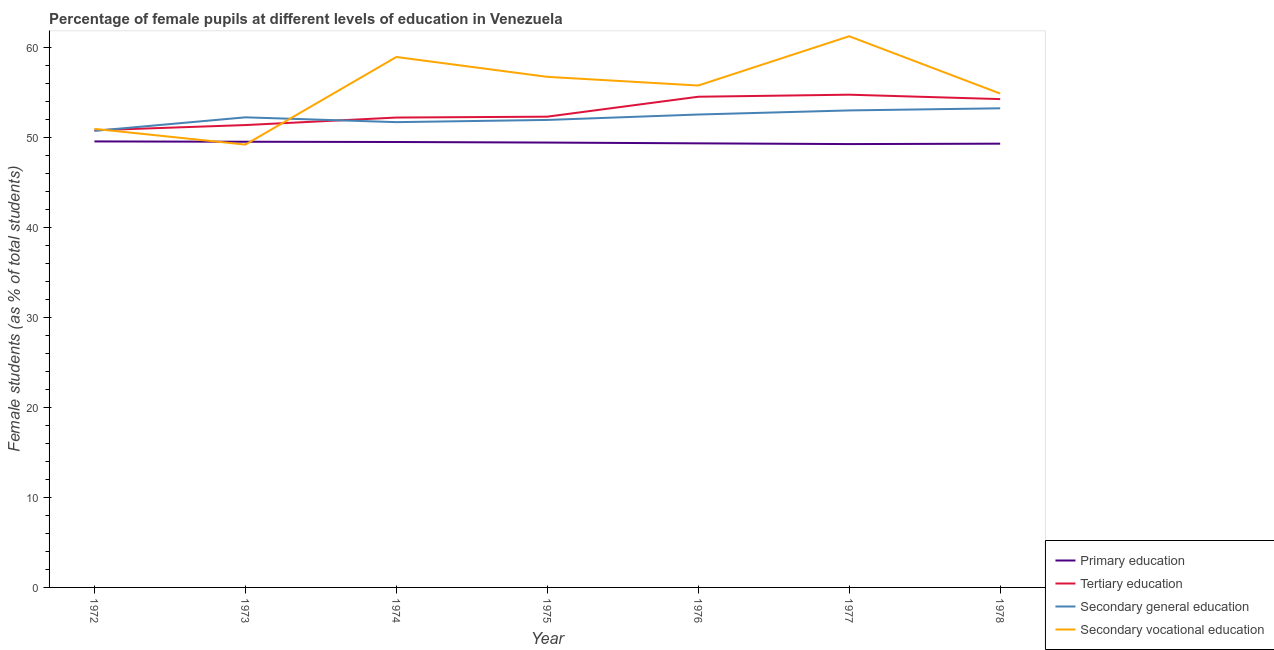Does the line corresponding to percentage of female students in tertiary education intersect with the line corresponding to percentage of female students in secondary vocational education?
Make the answer very short. Yes. Is the number of lines equal to the number of legend labels?
Provide a succinct answer. Yes. What is the percentage of female students in tertiary education in 1974?
Your answer should be compact. 52.25. Across all years, what is the maximum percentage of female students in secondary vocational education?
Provide a short and direct response. 61.29. Across all years, what is the minimum percentage of female students in secondary education?
Make the answer very short. 50.77. What is the total percentage of female students in secondary education in the graph?
Offer a terse response. 365.69. What is the difference between the percentage of female students in primary education in 1976 and that in 1977?
Offer a very short reply. 0.08. What is the difference between the percentage of female students in primary education in 1978 and the percentage of female students in secondary vocational education in 1977?
Offer a very short reply. -11.95. What is the average percentage of female students in primary education per year?
Your response must be concise. 49.46. In the year 1977, what is the difference between the percentage of female students in primary education and percentage of female students in tertiary education?
Make the answer very short. -5.49. In how many years, is the percentage of female students in primary education greater than 46 %?
Offer a very short reply. 7. What is the ratio of the percentage of female students in secondary education in 1972 to that in 1975?
Provide a short and direct response. 0.98. What is the difference between the highest and the second highest percentage of female students in tertiary education?
Your answer should be compact. 0.23. What is the difference between the highest and the lowest percentage of female students in secondary education?
Ensure brevity in your answer.  2.51. In how many years, is the percentage of female students in secondary vocational education greater than the average percentage of female students in secondary vocational education taken over all years?
Provide a succinct answer. 4. Is the sum of the percentage of female students in tertiary education in 1974 and 1977 greater than the maximum percentage of female students in secondary education across all years?
Make the answer very short. Yes. Is it the case that in every year, the sum of the percentage of female students in tertiary education and percentage of female students in primary education is greater than the sum of percentage of female students in secondary education and percentage of female students in secondary vocational education?
Your response must be concise. No. Is it the case that in every year, the sum of the percentage of female students in primary education and percentage of female students in tertiary education is greater than the percentage of female students in secondary education?
Your answer should be compact. Yes. Is the percentage of female students in secondary vocational education strictly less than the percentage of female students in primary education over the years?
Your answer should be compact. No. What is the difference between two consecutive major ticks on the Y-axis?
Give a very brief answer. 10. Are the values on the major ticks of Y-axis written in scientific E-notation?
Give a very brief answer. No. Where does the legend appear in the graph?
Provide a short and direct response. Bottom right. What is the title of the graph?
Provide a succinct answer. Percentage of female pupils at different levels of education in Venezuela. Does "Argument" appear as one of the legend labels in the graph?
Your answer should be very brief. No. What is the label or title of the X-axis?
Give a very brief answer. Year. What is the label or title of the Y-axis?
Give a very brief answer. Female students (as % of total students). What is the Female students (as % of total students) of Primary education in 1972?
Your answer should be compact. 49.6. What is the Female students (as % of total students) in Tertiary education in 1972?
Your answer should be very brief. 50.84. What is the Female students (as % of total students) of Secondary general education in 1972?
Provide a succinct answer. 50.77. What is the Female students (as % of total students) of Secondary vocational education in 1972?
Offer a terse response. 50.99. What is the Female students (as % of total students) in Primary education in 1973?
Your answer should be compact. 49.56. What is the Female students (as % of total students) of Tertiary education in 1973?
Your answer should be very brief. 51.42. What is the Female students (as % of total students) of Secondary general education in 1973?
Provide a short and direct response. 52.28. What is the Female students (as % of total students) in Secondary vocational education in 1973?
Your response must be concise. 49.24. What is the Female students (as % of total students) of Primary education in 1974?
Provide a succinct answer. 49.53. What is the Female students (as % of total students) of Tertiary education in 1974?
Your answer should be compact. 52.25. What is the Female students (as % of total students) of Secondary general education in 1974?
Ensure brevity in your answer.  51.74. What is the Female students (as % of total students) of Secondary vocational education in 1974?
Make the answer very short. 58.99. What is the Female students (as % of total students) in Primary education in 1975?
Offer a terse response. 49.47. What is the Female students (as % of total students) of Tertiary education in 1975?
Your answer should be very brief. 52.35. What is the Female students (as % of total students) in Secondary general education in 1975?
Offer a terse response. 51.99. What is the Female students (as % of total students) of Secondary vocational education in 1975?
Your answer should be very brief. 56.78. What is the Female students (as % of total students) in Primary education in 1976?
Your response must be concise. 49.38. What is the Female students (as % of total students) in Tertiary education in 1976?
Your response must be concise. 54.57. What is the Female students (as % of total students) of Secondary general education in 1976?
Give a very brief answer. 52.59. What is the Female students (as % of total students) of Secondary vocational education in 1976?
Offer a very short reply. 55.81. What is the Female students (as % of total students) in Primary education in 1977?
Make the answer very short. 49.3. What is the Female students (as % of total students) of Tertiary education in 1977?
Offer a very short reply. 54.79. What is the Female students (as % of total students) of Secondary general education in 1977?
Provide a succinct answer. 53.04. What is the Female students (as % of total students) of Secondary vocational education in 1977?
Your answer should be very brief. 61.29. What is the Female students (as % of total students) of Primary education in 1978?
Your answer should be compact. 49.35. What is the Female students (as % of total students) in Tertiary education in 1978?
Make the answer very short. 54.3. What is the Female students (as % of total students) of Secondary general education in 1978?
Give a very brief answer. 53.28. What is the Female students (as % of total students) of Secondary vocational education in 1978?
Offer a terse response. 54.92. Across all years, what is the maximum Female students (as % of total students) in Primary education?
Make the answer very short. 49.6. Across all years, what is the maximum Female students (as % of total students) in Tertiary education?
Your answer should be very brief. 54.79. Across all years, what is the maximum Female students (as % of total students) in Secondary general education?
Provide a short and direct response. 53.28. Across all years, what is the maximum Female students (as % of total students) of Secondary vocational education?
Ensure brevity in your answer.  61.29. Across all years, what is the minimum Female students (as % of total students) of Primary education?
Ensure brevity in your answer.  49.3. Across all years, what is the minimum Female students (as % of total students) in Tertiary education?
Give a very brief answer. 50.84. Across all years, what is the minimum Female students (as % of total students) of Secondary general education?
Your response must be concise. 50.77. Across all years, what is the minimum Female students (as % of total students) of Secondary vocational education?
Offer a terse response. 49.24. What is the total Female students (as % of total students) of Primary education in the graph?
Offer a terse response. 346.19. What is the total Female students (as % of total students) of Tertiary education in the graph?
Your answer should be very brief. 370.52. What is the total Female students (as % of total students) in Secondary general education in the graph?
Provide a short and direct response. 365.69. What is the total Female students (as % of total students) in Secondary vocational education in the graph?
Provide a short and direct response. 388.03. What is the difference between the Female students (as % of total students) in Primary education in 1972 and that in 1973?
Make the answer very short. 0.03. What is the difference between the Female students (as % of total students) in Tertiary education in 1972 and that in 1973?
Give a very brief answer. -0.58. What is the difference between the Female students (as % of total students) of Secondary general education in 1972 and that in 1973?
Offer a very short reply. -1.5. What is the difference between the Female students (as % of total students) of Secondary vocational education in 1972 and that in 1973?
Keep it short and to the point. 1.75. What is the difference between the Female students (as % of total students) in Primary education in 1972 and that in 1974?
Offer a very short reply. 0.06. What is the difference between the Female students (as % of total students) of Tertiary education in 1972 and that in 1974?
Offer a very short reply. -1.42. What is the difference between the Female students (as % of total students) in Secondary general education in 1972 and that in 1974?
Give a very brief answer. -0.97. What is the difference between the Female students (as % of total students) in Secondary vocational education in 1972 and that in 1974?
Provide a succinct answer. -7.99. What is the difference between the Female students (as % of total students) of Primary education in 1972 and that in 1975?
Ensure brevity in your answer.  0.13. What is the difference between the Female students (as % of total students) in Tertiary education in 1972 and that in 1975?
Keep it short and to the point. -1.51. What is the difference between the Female students (as % of total students) in Secondary general education in 1972 and that in 1975?
Provide a short and direct response. -1.21. What is the difference between the Female students (as % of total students) of Secondary vocational education in 1972 and that in 1975?
Your answer should be compact. -5.79. What is the difference between the Female students (as % of total students) in Primary education in 1972 and that in 1976?
Offer a very short reply. 0.21. What is the difference between the Female students (as % of total students) of Tertiary education in 1972 and that in 1976?
Offer a very short reply. -3.73. What is the difference between the Female students (as % of total students) of Secondary general education in 1972 and that in 1976?
Your answer should be very brief. -1.82. What is the difference between the Female students (as % of total students) in Secondary vocational education in 1972 and that in 1976?
Provide a succinct answer. -4.82. What is the difference between the Female students (as % of total students) in Primary education in 1972 and that in 1977?
Keep it short and to the point. 0.3. What is the difference between the Female students (as % of total students) in Tertiary education in 1972 and that in 1977?
Offer a terse response. -3.96. What is the difference between the Female students (as % of total students) in Secondary general education in 1972 and that in 1977?
Provide a succinct answer. -2.27. What is the difference between the Female students (as % of total students) in Secondary vocational education in 1972 and that in 1977?
Make the answer very short. -10.3. What is the difference between the Female students (as % of total students) in Primary education in 1972 and that in 1978?
Ensure brevity in your answer.  0.25. What is the difference between the Female students (as % of total students) in Tertiary education in 1972 and that in 1978?
Provide a short and direct response. -3.47. What is the difference between the Female students (as % of total students) of Secondary general education in 1972 and that in 1978?
Make the answer very short. -2.51. What is the difference between the Female students (as % of total students) in Secondary vocational education in 1972 and that in 1978?
Ensure brevity in your answer.  -3.93. What is the difference between the Female students (as % of total students) in Primary education in 1973 and that in 1974?
Provide a short and direct response. 0.03. What is the difference between the Female students (as % of total students) of Tertiary education in 1973 and that in 1974?
Offer a terse response. -0.83. What is the difference between the Female students (as % of total students) of Secondary general education in 1973 and that in 1974?
Provide a short and direct response. 0.53. What is the difference between the Female students (as % of total students) of Secondary vocational education in 1973 and that in 1974?
Your answer should be very brief. -9.74. What is the difference between the Female students (as % of total students) of Primary education in 1973 and that in 1975?
Provide a succinct answer. 0.09. What is the difference between the Female students (as % of total students) in Tertiary education in 1973 and that in 1975?
Your response must be concise. -0.93. What is the difference between the Female students (as % of total students) in Secondary general education in 1973 and that in 1975?
Provide a succinct answer. 0.29. What is the difference between the Female students (as % of total students) in Secondary vocational education in 1973 and that in 1975?
Your response must be concise. -7.53. What is the difference between the Female students (as % of total students) of Primary education in 1973 and that in 1976?
Make the answer very short. 0.18. What is the difference between the Female students (as % of total students) of Tertiary education in 1973 and that in 1976?
Give a very brief answer. -3.15. What is the difference between the Female students (as % of total students) of Secondary general education in 1973 and that in 1976?
Your response must be concise. -0.31. What is the difference between the Female students (as % of total students) in Secondary vocational education in 1973 and that in 1976?
Make the answer very short. -6.57. What is the difference between the Female students (as % of total students) of Primary education in 1973 and that in 1977?
Offer a very short reply. 0.26. What is the difference between the Female students (as % of total students) of Tertiary education in 1973 and that in 1977?
Provide a short and direct response. -3.38. What is the difference between the Female students (as % of total students) in Secondary general education in 1973 and that in 1977?
Your answer should be compact. -0.77. What is the difference between the Female students (as % of total students) in Secondary vocational education in 1973 and that in 1977?
Make the answer very short. -12.05. What is the difference between the Female students (as % of total students) of Primary education in 1973 and that in 1978?
Offer a terse response. 0.22. What is the difference between the Female students (as % of total students) in Tertiary education in 1973 and that in 1978?
Keep it short and to the point. -2.89. What is the difference between the Female students (as % of total students) of Secondary general education in 1973 and that in 1978?
Give a very brief answer. -1. What is the difference between the Female students (as % of total students) of Secondary vocational education in 1973 and that in 1978?
Ensure brevity in your answer.  -5.68. What is the difference between the Female students (as % of total students) of Primary education in 1974 and that in 1975?
Provide a succinct answer. 0.06. What is the difference between the Female students (as % of total students) of Tertiary education in 1974 and that in 1975?
Make the answer very short. -0.1. What is the difference between the Female students (as % of total students) in Secondary general education in 1974 and that in 1975?
Give a very brief answer. -0.24. What is the difference between the Female students (as % of total students) in Secondary vocational education in 1974 and that in 1975?
Offer a very short reply. 2.21. What is the difference between the Female students (as % of total students) in Primary education in 1974 and that in 1976?
Your response must be concise. 0.15. What is the difference between the Female students (as % of total students) in Tertiary education in 1974 and that in 1976?
Ensure brevity in your answer.  -2.31. What is the difference between the Female students (as % of total students) in Secondary general education in 1974 and that in 1976?
Provide a short and direct response. -0.85. What is the difference between the Female students (as % of total students) in Secondary vocational education in 1974 and that in 1976?
Make the answer very short. 3.17. What is the difference between the Female students (as % of total students) of Primary education in 1974 and that in 1977?
Give a very brief answer. 0.23. What is the difference between the Female students (as % of total students) of Tertiary education in 1974 and that in 1977?
Your answer should be compact. -2.54. What is the difference between the Female students (as % of total students) in Secondary general education in 1974 and that in 1977?
Provide a short and direct response. -1.3. What is the difference between the Female students (as % of total students) of Secondary vocational education in 1974 and that in 1977?
Your answer should be very brief. -2.31. What is the difference between the Female students (as % of total students) in Primary education in 1974 and that in 1978?
Provide a succinct answer. 0.19. What is the difference between the Female students (as % of total students) of Tertiary education in 1974 and that in 1978?
Provide a short and direct response. -2.05. What is the difference between the Female students (as % of total students) of Secondary general education in 1974 and that in 1978?
Make the answer very short. -1.54. What is the difference between the Female students (as % of total students) in Secondary vocational education in 1974 and that in 1978?
Make the answer very short. 4.06. What is the difference between the Female students (as % of total students) in Primary education in 1975 and that in 1976?
Your answer should be very brief. 0.09. What is the difference between the Female students (as % of total students) in Tertiary education in 1975 and that in 1976?
Offer a terse response. -2.22. What is the difference between the Female students (as % of total students) of Secondary general education in 1975 and that in 1976?
Ensure brevity in your answer.  -0.6. What is the difference between the Female students (as % of total students) in Secondary vocational education in 1975 and that in 1976?
Offer a terse response. 0.96. What is the difference between the Female students (as % of total students) of Primary education in 1975 and that in 1977?
Keep it short and to the point. 0.17. What is the difference between the Female students (as % of total students) in Tertiary education in 1975 and that in 1977?
Keep it short and to the point. -2.44. What is the difference between the Female students (as % of total students) in Secondary general education in 1975 and that in 1977?
Your answer should be compact. -1.06. What is the difference between the Female students (as % of total students) in Secondary vocational education in 1975 and that in 1977?
Give a very brief answer. -4.52. What is the difference between the Female students (as % of total students) in Primary education in 1975 and that in 1978?
Your response must be concise. 0.12. What is the difference between the Female students (as % of total students) of Tertiary education in 1975 and that in 1978?
Make the answer very short. -1.95. What is the difference between the Female students (as % of total students) of Secondary general education in 1975 and that in 1978?
Your response must be concise. -1.29. What is the difference between the Female students (as % of total students) of Secondary vocational education in 1975 and that in 1978?
Give a very brief answer. 1.86. What is the difference between the Female students (as % of total students) in Primary education in 1976 and that in 1977?
Give a very brief answer. 0.08. What is the difference between the Female students (as % of total students) in Tertiary education in 1976 and that in 1977?
Make the answer very short. -0.23. What is the difference between the Female students (as % of total students) of Secondary general education in 1976 and that in 1977?
Ensure brevity in your answer.  -0.46. What is the difference between the Female students (as % of total students) of Secondary vocational education in 1976 and that in 1977?
Provide a short and direct response. -5.48. What is the difference between the Female students (as % of total students) of Primary education in 1976 and that in 1978?
Make the answer very short. 0.04. What is the difference between the Female students (as % of total students) of Tertiary education in 1976 and that in 1978?
Provide a succinct answer. 0.26. What is the difference between the Female students (as % of total students) of Secondary general education in 1976 and that in 1978?
Your answer should be compact. -0.69. What is the difference between the Female students (as % of total students) of Secondary vocational education in 1976 and that in 1978?
Keep it short and to the point. 0.89. What is the difference between the Female students (as % of total students) of Primary education in 1977 and that in 1978?
Give a very brief answer. -0.05. What is the difference between the Female students (as % of total students) of Tertiary education in 1977 and that in 1978?
Provide a short and direct response. 0.49. What is the difference between the Female students (as % of total students) in Secondary general education in 1977 and that in 1978?
Keep it short and to the point. -0.24. What is the difference between the Female students (as % of total students) of Secondary vocational education in 1977 and that in 1978?
Offer a terse response. 6.37. What is the difference between the Female students (as % of total students) in Primary education in 1972 and the Female students (as % of total students) in Tertiary education in 1973?
Your response must be concise. -1.82. What is the difference between the Female students (as % of total students) of Primary education in 1972 and the Female students (as % of total students) of Secondary general education in 1973?
Keep it short and to the point. -2.68. What is the difference between the Female students (as % of total students) of Primary education in 1972 and the Female students (as % of total students) of Secondary vocational education in 1973?
Offer a terse response. 0.35. What is the difference between the Female students (as % of total students) of Tertiary education in 1972 and the Female students (as % of total students) of Secondary general education in 1973?
Provide a short and direct response. -1.44. What is the difference between the Female students (as % of total students) in Tertiary education in 1972 and the Female students (as % of total students) in Secondary vocational education in 1973?
Provide a succinct answer. 1.59. What is the difference between the Female students (as % of total students) of Secondary general education in 1972 and the Female students (as % of total students) of Secondary vocational education in 1973?
Your answer should be very brief. 1.53. What is the difference between the Female students (as % of total students) of Primary education in 1972 and the Female students (as % of total students) of Tertiary education in 1974?
Your response must be concise. -2.65. What is the difference between the Female students (as % of total students) of Primary education in 1972 and the Female students (as % of total students) of Secondary general education in 1974?
Your answer should be very brief. -2.14. What is the difference between the Female students (as % of total students) of Primary education in 1972 and the Female students (as % of total students) of Secondary vocational education in 1974?
Your response must be concise. -9.39. What is the difference between the Female students (as % of total students) in Tertiary education in 1972 and the Female students (as % of total students) in Secondary general education in 1974?
Your response must be concise. -0.91. What is the difference between the Female students (as % of total students) of Tertiary education in 1972 and the Female students (as % of total students) of Secondary vocational education in 1974?
Provide a succinct answer. -8.15. What is the difference between the Female students (as % of total students) of Secondary general education in 1972 and the Female students (as % of total students) of Secondary vocational education in 1974?
Your response must be concise. -8.21. What is the difference between the Female students (as % of total students) of Primary education in 1972 and the Female students (as % of total students) of Tertiary education in 1975?
Your answer should be compact. -2.75. What is the difference between the Female students (as % of total students) of Primary education in 1972 and the Female students (as % of total students) of Secondary general education in 1975?
Offer a very short reply. -2.39. What is the difference between the Female students (as % of total students) in Primary education in 1972 and the Female students (as % of total students) in Secondary vocational education in 1975?
Offer a very short reply. -7.18. What is the difference between the Female students (as % of total students) in Tertiary education in 1972 and the Female students (as % of total students) in Secondary general education in 1975?
Give a very brief answer. -1.15. What is the difference between the Female students (as % of total students) of Tertiary education in 1972 and the Female students (as % of total students) of Secondary vocational education in 1975?
Ensure brevity in your answer.  -5.94. What is the difference between the Female students (as % of total students) of Secondary general education in 1972 and the Female students (as % of total students) of Secondary vocational education in 1975?
Give a very brief answer. -6.01. What is the difference between the Female students (as % of total students) in Primary education in 1972 and the Female students (as % of total students) in Tertiary education in 1976?
Provide a succinct answer. -4.97. What is the difference between the Female students (as % of total students) of Primary education in 1972 and the Female students (as % of total students) of Secondary general education in 1976?
Offer a very short reply. -2.99. What is the difference between the Female students (as % of total students) in Primary education in 1972 and the Female students (as % of total students) in Secondary vocational education in 1976?
Provide a succinct answer. -6.22. What is the difference between the Female students (as % of total students) of Tertiary education in 1972 and the Female students (as % of total students) of Secondary general education in 1976?
Offer a very short reply. -1.75. What is the difference between the Female students (as % of total students) in Tertiary education in 1972 and the Female students (as % of total students) in Secondary vocational education in 1976?
Ensure brevity in your answer.  -4.98. What is the difference between the Female students (as % of total students) in Secondary general education in 1972 and the Female students (as % of total students) in Secondary vocational education in 1976?
Make the answer very short. -5.04. What is the difference between the Female students (as % of total students) of Primary education in 1972 and the Female students (as % of total students) of Tertiary education in 1977?
Provide a succinct answer. -5.2. What is the difference between the Female students (as % of total students) of Primary education in 1972 and the Female students (as % of total students) of Secondary general education in 1977?
Offer a terse response. -3.45. What is the difference between the Female students (as % of total students) of Primary education in 1972 and the Female students (as % of total students) of Secondary vocational education in 1977?
Ensure brevity in your answer.  -11.7. What is the difference between the Female students (as % of total students) of Tertiary education in 1972 and the Female students (as % of total students) of Secondary general education in 1977?
Your answer should be very brief. -2.21. What is the difference between the Female students (as % of total students) of Tertiary education in 1972 and the Female students (as % of total students) of Secondary vocational education in 1977?
Give a very brief answer. -10.46. What is the difference between the Female students (as % of total students) in Secondary general education in 1972 and the Female students (as % of total students) in Secondary vocational education in 1977?
Your response must be concise. -10.52. What is the difference between the Female students (as % of total students) of Primary education in 1972 and the Female students (as % of total students) of Tertiary education in 1978?
Your answer should be very brief. -4.71. What is the difference between the Female students (as % of total students) of Primary education in 1972 and the Female students (as % of total students) of Secondary general education in 1978?
Keep it short and to the point. -3.68. What is the difference between the Female students (as % of total students) in Primary education in 1972 and the Female students (as % of total students) in Secondary vocational education in 1978?
Ensure brevity in your answer.  -5.32. What is the difference between the Female students (as % of total students) of Tertiary education in 1972 and the Female students (as % of total students) of Secondary general education in 1978?
Ensure brevity in your answer.  -2.44. What is the difference between the Female students (as % of total students) in Tertiary education in 1972 and the Female students (as % of total students) in Secondary vocational education in 1978?
Your answer should be very brief. -4.08. What is the difference between the Female students (as % of total students) of Secondary general education in 1972 and the Female students (as % of total students) of Secondary vocational education in 1978?
Provide a short and direct response. -4.15. What is the difference between the Female students (as % of total students) of Primary education in 1973 and the Female students (as % of total students) of Tertiary education in 1974?
Give a very brief answer. -2.69. What is the difference between the Female students (as % of total students) of Primary education in 1973 and the Female students (as % of total students) of Secondary general education in 1974?
Ensure brevity in your answer.  -2.18. What is the difference between the Female students (as % of total students) in Primary education in 1973 and the Female students (as % of total students) in Secondary vocational education in 1974?
Make the answer very short. -9.42. What is the difference between the Female students (as % of total students) of Tertiary education in 1973 and the Female students (as % of total students) of Secondary general education in 1974?
Provide a short and direct response. -0.33. What is the difference between the Female students (as % of total students) of Tertiary education in 1973 and the Female students (as % of total students) of Secondary vocational education in 1974?
Your answer should be very brief. -7.57. What is the difference between the Female students (as % of total students) of Secondary general education in 1973 and the Female students (as % of total students) of Secondary vocational education in 1974?
Provide a short and direct response. -6.71. What is the difference between the Female students (as % of total students) of Primary education in 1973 and the Female students (as % of total students) of Tertiary education in 1975?
Provide a succinct answer. -2.79. What is the difference between the Female students (as % of total students) of Primary education in 1973 and the Female students (as % of total students) of Secondary general education in 1975?
Your response must be concise. -2.42. What is the difference between the Female students (as % of total students) in Primary education in 1973 and the Female students (as % of total students) in Secondary vocational education in 1975?
Your answer should be very brief. -7.22. What is the difference between the Female students (as % of total students) of Tertiary education in 1973 and the Female students (as % of total students) of Secondary general education in 1975?
Provide a succinct answer. -0.57. What is the difference between the Female students (as % of total students) of Tertiary education in 1973 and the Female students (as % of total students) of Secondary vocational education in 1975?
Your answer should be very brief. -5.36. What is the difference between the Female students (as % of total students) in Secondary general education in 1973 and the Female students (as % of total students) in Secondary vocational education in 1975?
Ensure brevity in your answer.  -4.5. What is the difference between the Female students (as % of total students) in Primary education in 1973 and the Female students (as % of total students) in Tertiary education in 1976?
Make the answer very short. -5. What is the difference between the Female students (as % of total students) in Primary education in 1973 and the Female students (as % of total students) in Secondary general education in 1976?
Your answer should be compact. -3.03. What is the difference between the Female students (as % of total students) in Primary education in 1973 and the Female students (as % of total students) in Secondary vocational education in 1976?
Provide a short and direct response. -6.25. What is the difference between the Female students (as % of total students) of Tertiary education in 1973 and the Female students (as % of total students) of Secondary general education in 1976?
Your response must be concise. -1.17. What is the difference between the Female students (as % of total students) in Tertiary education in 1973 and the Female students (as % of total students) in Secondary vocational education in 1976?
Provide a succinct answer. -4.4. What is the difference between the Female students (as % of total students) of Secondary general education in 1973 and the Female students (as % of total students) of Secondary vocational education in 1976?
Make the answer very short. -3.54. What is the difference between the Female students (as % of total students) in Primary education in 1973 and the Female students (as % of total students) in Tertiary education in 1977?
Your response must be concise. -5.23. What is the difference between the Female students (as % of total students) of Primary education in 1973 and the Female students (as % of total students) of Secondary general education in 1977?
Offer a terse response. -3.48. What is the difference between the Female students (as % of total students) of Primary education in 1973 and the Female students (as % of total students) of Secondary vocational education in 1977?
Offer a very short reply. -11.73. What is the difference between the Female students (as % of total students) of Tertiary education in 1973 and the Female students (as % of total students) of Secondary general education in 1977?
Your response must be concise. -1.63. What is the difference between the Female students (as % of total students) of Tertiary education in 1973 and the Female students (as % of total students) of Secondary vocational education in 1977?
Your answer should be compact. -9.88. What is the difference between the Female students (as % of total students) of Secondary general education in 1973 and the Female students (as % of total students) of Secondary vocational education in 1977?
Your answer should be very brief. -9.02. What is the difference between the Female students (as % of total students) in Primary education in 1973 and the Female students (as % of total students) in Tertiary education in 1978?
Your response must be concise. -4.74. What is the difference between the Female students (as % of total students) in Primary education in 1973 and the Female students (as % of total students) in Secondary general education in 1978?
Give a very brief answer. -3.72. What is the difference between the Female students (as % of total students) of Primary education in 1973 and the Female students (as % of total students) of Secondary vocational education in 1978?
Your answer should be very brief. -5.36. What is the difference between the Female students (as % of total students) of Tertiary education in 1973 and the Female students (as % of total students) of Secondary general education in 1978?
Give a very brief answer. -1.86. What is the difference between the Female students (as % of total students) of Tertiary education in 1973 and the Female students (as % of total students) of Secondary vocational education in 1978?
Provide a short and direct response. -3.5. What is the difference between the Female students (as % of total students) in Secondary general education in 1973 and the Female students (as % of total students) in Secondary vocational education in 1978?
Ensure brevity in your answer.  -2.64. What is the difference between the Female students (as % of total students) in Primary education in 1974 and the Female students (as % of total students) in Tertiary education in 1975?
Provide a succinct answer. -2.82. What is the difference between the Female students (as % of total students) in Primary education in 1974 and the Female students (as % of total students) in Secondary general education in 1975?
Make the answer very short. -2.45. What is the difference between the Female students (as % of total students) in Primary education in 1974 and the Female students (as % of total students) in Secondary vocational education in 1975?
Provide a succinct answer. -7.25. What is the difference between the Female students (as % of total students) of Tertiary education in 1974 and the Female students (as % of total students) of Secondary general education in 1975?
Offer a very short reply. 0.27. What is the difference between the Female students (as % of total students) in Tertiary education in 1974 and the Female students (as % of total students) in Secondary vocational education in 1975?
Your answer should be very brief. -4.53. What is the difference between the Female students (as % of total students) of Secondary general education in 1974 and the Female students (as % of total students) of Secondary vocational education in 1975?
Your response must be concise. -5.04. What is the difference between the Female students (as % of total students) of Primary education in 1974 and the Female students (as % of total students) of Tertiary education in 1976?
Make the answer very short. -5.03. What is the difference between the Female students (as % of total students) in Primary education in 1974 and the Female students (as % of total students) in Secondary general education in 1976?
Offer a very short reply. -3.06. What is the difference between the Female students (as % of total students) of Primary education in 1974 and the Female students (as % of total students) of Secondary vocational education in 1976?
Your answer should be very brief. -6.28. What is the difference between the Female students (as % of total students) in Tertiary education in 1974 and the Female students (as % of total students) in Secondary general education in 1976?
Offer a terse response. -0.34. What is the difference between the Female students (as % of total students) of Tertiary education in 1974 and the Female students (as % of total students) of Secondary vocational education in 1976?
Provide a short and direct response. -3.56. What is the difference between the Female students (as % of total students) in Secondary general education in 1974 and the Female students (as % of total students) in Secondary vocational education in 1976?
Provide a short and direct response. -4.07. What is the difference between the Female students (as % of total students) in Primary education in 1974 and the Female students (as % of total students) in Tertiary education in 1977?
Provide a short and direct response. -5.26. What is the difference between the Female students (as % of total students) in Primary education in 1974 and the Female students (as % of total students) in Secondary general education in 1977?
Ensure brevity in your answer.  -3.51. What is the difference between the Female students (as % of total students) of Primary education in 1974 and the Female students (as % of total students) of Secondary vocational education in 1977?
Offer a terse response. -11.76. What is the difference between the Female students (as % of total students) of Tertiary education in 1974 and the Female students (as % of total students) of Secondary general education in 1977?
Keep it short and to the point. -0.79. What is the difference between the Female students (as % of total students) in Tertiary education in 1974 and the Female students (as % of total students) in Secondary vocational education in 1977?
Offer a terse response. -9.04. What is the difference between the Female students (as % of total students) of Secondary general education in 1974 and the Female students (as % of total students) of Secondary vocational education in 1977?
Ensure brevity in your answer.  -9.55. What is the difference between the Female students (as % of total students) in Primary education in 1974 and the Female students (as % of total students) in Tertiary education in 1978?
Make the answer very short. -4.77. What is the difference between the Female students (as % of total students) in Primary education in 1974 and the Female students (as % of total students) in Secondary general education in 1978?
Give a very brief answer. -3.75. What is the difference between the Female students (as % of total students) of Primary education in 1974 and the Female students (as % of total students) of Secondary vocational education in 1978?
Keep it short and to the point. -5.39. What is the difference between the Female students (as % of total students) of Tertiary education in 1974 and the Female students (as % of total students) of Secondary general education in 1978?
Offer a terse response. -1.03. What is the difference between the Female students (as % of total students) of Tertiary education in 1974 and the Female students (as % of total students) of Secondary vocational education in 1978?
Your response must be concise. -2.67. What is the difference between the Female students (as % of total students) of Secondary general education in 1974 and the Female students (as % of total students) of Secondary vocational education in 1978?
Your answer should be compact. -3.18. What is the difference between the Female students (as % of total students) of Primary education in 1975 and the Female students (as % of total students) of Tertiary education in 1976?
Offer a terse response. -5.09. What is the difference between the Female students (as % of total students) of Primary education in 1975 and the Female students (as % of total students) of Secondary general education in 1976?
Ensure brevity in your answer.  -3.12. What is the difference between the Female students (as % of total students) in Primary education in 1975 and the Female students (as % of total students) in Secondary vocational education in 1976?
Offer a very short reply. -6.34. What is the difference between the Female students (as % of total students) in Tertiary education in 1975 and the Female students (as % of total students) in Secondary general education in 1976?
Keep it short and to the point. -0.24. What is the difference between the Female students (as % of total students) of Tertiary education in 1975 and the Female students (as % of total students) of Secondary vocational education in 1976?
Provide a succinct answer. -3.46. What is the difference between the Female students (as % of total students) of Secondary general education in 1975 and the Female students (as % of total students) of Secondary vocational education in 1976?
Provide a succinct answer. -3.83. What is the difference between the Female students (as % of total students) of Primary education in 1975 and the Female students (as % of total students) of Tertiary education in 1977?
Keep it short and to the point. -5.32. What is the difference between the Female students (as % of total students) of Primary education in 1975 and the Female students (as % of total students) of Secondary general education in 1977?
Your response must be concise. -3.57. What is the difference between the Female students (as % of total students) of Primary education in 1975 and the Female students (as % of total students) of Secondary vocational education in 1977?
Provide a short and direct response. -11.82. What is the difference between the Female students (as % of total students) in Tertiary education in 1975 and the Female students (as % of total students) in Secondary general education in 1977?
Keep it short and to the point. -0.69. What is the difference between the Female students (as % of total students) in Tertiary education in 1975 and the Female students (as % of total students) in Secondary vocational education in 1977?
Offer a terse response. -8.94. What is the difference between the Female students (as % of total students) of Secondary general education in 1975 and the Female students (as % of total students) of Secondary vocational education in 1977?
Keep it short and to the point. -9.31. What is the difference between the Female students (as % of total students) in Primary education in 1975 and the Female students (as % of total students) in Tertiary education in 1978?
Offer a very short reply. -4.83. What is the difference between the Female students (as % of total students) in Primary education in 1975 and the Female students (as % of total students) in Secondary general education in 1978?
Your response must be concise. -3.81. What is the difference between the Female students (as % of total students) in Primary education in 1975 and the Female students (as % of total students) in Secondary vocational education in 1978?
Your response must be concise. -5.45. What is the difference between the Female students (as % of total students) of Tertiary education in 1975 and the Female students (as % of total students) of Secondary general education in 1978?
Keep it short and to the point. -0.93. What is the difference between the Female students (as % of total students) of Tertiary education in 1975 and the Female students (as % of total students) of Secondary vocational education in 1978?
Keep it short and to the point. -2.57. What is the difference between the Female students (as % of total students) of Secondary general education in 1975 and the Female students (as % of total students) of Secondary vocational education in 1978?
Provide a succinct answer. -2.94. What is the difference between the Female students (as % of total students) in Primary education in 1976 and the Female students (as % of total students) in Tertiary education in 1977?
Ensure brevity in your answer.  -5.41. What is the difference between the Female students (as % of total students) in Primary education in 1976 and the Female students (as % of total students) in Secondary general education in 1977?
Give a very brief answer. -3.66. What is the difference between the Female students (as % of total students) of Primary education in 1976 and the Female students (as % of total students) of Secondary vocational education in 1977?
Your answer should be very brief. -11.91. What is the difference between the Female students (as % of total students) in Tertiary education in 1976 and the Female students (as % of total students) in Secondary general education in 1977?
Your answer should be compact. 1.52. What is the difference between the Female students (as % of total students) in Tertiary education in 1976 and the Female students (as % of total students) in Secondary vocational education in 1977?
Ensure brevity in your answer.  -6.73. What is the difference between the Female students (as % of total students) of Secondary general education in 1976 and the Female students (as % of total students) of Secondary vocational education in 1977?
Your response must be concise. -8.7. What is the difference between the Female students (as % of total students) in Primary education in 1976 and the Female students (as % of total students) in Tertiary education in 1978?
Ensure brevity in your answer.  -4.92. What is the difference between the Female students (as % of total students) in Primary education in 1976 and the Female students (as % of total students) in Secondary general education in 1978?
Offer a very short reply. -3.9. What is the difference between the Female students (as % of total students) of Primary education in 1976 and the Female students (as % of total students) of Secondary vocational education in 1978?
Your response must be concise. -5.54. What is the difference between the Female students (as % of total students) in Tertiary education in 1976 and the Female students (as % of total students) in Secondary general education in 1978?
Your answer should be very brief. 1.29. What is the difference between the Female students (as % of total students) in Tertiary education in 1976 and the Female students (as % of total students) in Secondary vocational education in 1978?
Your answer should be compact. -0.35. What is the difference between the Female students (as % of total students) in Secondary general education in 1976 and the Female students (as % of total students) in Secondary vocational education in 1978?
Offer a terse response. -2.33. What is the difference between the Female students (as % of total students) in Primary education in 1977 and the Female students (as % of total students) in Tertiary education in 1978?
Offer a terse response. -5. What is the difference between the Female students (as % of total students) in Primary education in 1977 and the Female students (as % of total students) in Secondary general education in 1978?
Provide a short and direct response. -3.98. What is the difference between the Female students (as % of total students) of Primary education in 1977 and the Female students (as % of total students) of Secondary vocational education in 1978?
Your answer should be compact. -5.62. What is the difference between the Female students (as % of total students) in Tertiary education in 1977 and the Female students (as % of total students) in Secondary general education in 1978?
Offer a very short reply. 1.51. What is the difference between the Female students (as % of total students) in Tertiary education in 1977 and the Female students (as % of total students) in Secondary vocational education in 1978?
Make the answer very short. -0.13. What is the difference between the Female students (as % of total students) of Secondary general education in 1977 and the Female students (as % of total students) of Secondary vocational education in 1978?
Ensure brevity in your answer.  -1.88. What is the average Female students (as % of total students) of Primary education per year?
Your answer should be compact. 49.46. What is the average Female students (as % of total students) in Tertiary education per year?
Provide a succinct answer. 52.93. What is the average Female students (as % of total students) in Secondary general education per year?
Provide a short and direct response. 52.24. What is the average Female students (as % of total students) in Secondary vocational education per year?
Ensure brevity in your answer.  55.43. In the year 1972, what is the difference between the Female students (as % of total students) of Primary education and Female students (as % of total students) of Tertiary education?
Ensure brevity in your answer.  -1.24. In the year 1972, what is the difference between the Female students (as % of total students) in Primary education and Female students (as % of total students) in Secondary general education?
Ensure brevity in your answer.  -1.18. In the year 1972, what is the difference between the Female students (as % of total students) in Primary education and Female students (as % of total students) in Secondary vocational education?
Give a very brief answer. -1.4. In the year 1972, what is the difference between the Female students (as % of total students) of Tertiary education and Female students (as % of total students) of Secondary general education?
Provide a short and direct response. 0.06. In the year 1972, what is the difference between the Female students (as % of total students) of Tertiary education and Female students (as % of total students) of Secondary vocational education?
Ensure brevity in your answer.  -0.16. In the year 1972, what is the difference between the Female students (as % of total students) in Secondary general education and Female students (as % of total students) in Secondary vocational education?
Offer a very short reply. -0.22. In the year 1973, what is the difference between the Female students (as % of total students) of Primary education and Female students (as % of total students) of Tertiary education?
Provide a short and direct response. -1.85. In the year 1973, what is the difference between the Female students (as % of total students) in Primary education and Female students (as % of total students) in Secondary general education?
Give a very brief answer. -2.71. In the year 1973, what is the difference between the Female students (as % of total students) of Primary education and Female students (as % of total students) of Secondary vocational education?
Give a very brief answer. 0.32. In the year 1973, what is the difference between the Female students (as % of total students) in Tertiary education and Female students (as % of total students) in Secondary general education?
Give a very brief answer. -0.86. In the year 1973, what is the difference between the Female students (as % of total students) in Tertiary education and Female students (as % of total students) in Secondary vocational education?
Offer a very short reply. 2.17. In the year 1973, what is the difference between the Female students (as % of total students) of Secondary general education and Female students (as % of total students) of Secondary vocational education?
Your answer should be compact. 3.03. In the year 1974, what is the difference between the Female students (as % of total students) of Primary education and Female students (as % of total students) of Tertiary education?
Make the answer very short. -2.72. In the year 1974, what is the difference between the Female students (as % of total students) of Primary education and Female students (as % of total students) of Secondary general education?
Offer a very short reply. -2.21. In the year 1974, what is the difference between the Female students (as % of total students) of Primary education and Female students (as % of total students) of Secondary vocational education?
Provide a succinct answer. -9.45. In the year 1974, what is the difference between the Female students (as % of total students) in Tertiary education and Female students (as % of total students) in Secondary general education?
Offer a very short reply. 0.51. In the year 1974, what is the difference between the Female students (as % of total students) of Tertiary education and Female students (as % of total students) of Secondary vocational education?
Your answer should be compact. -6.73. In the year 1974, what is the difference between the Female students (as % of total students) of Secondary general education and Female students (as % of total students) of Secondary vocational education?
Your answer should be very brief. -7.24. In the year 1975, what is the difference between the Female students (as % of total students) of Primary education and Female students (as % of total students) of Tertiary education?
Keep it short and to the point. -2.88. In the year 1975, what is the difference between the Female students (as % of total students) in Primary education and Female students (as % of total students) in Secondary general education?
Provide a short and direct response. -2.51. In the year 1975, what is the difference between the Female students (as % of total students) of Primary education and Female students (as % of total students) of Secondary vocational education?
Ensure brevity in your answer.  -7.31. In the year 1975, what is the difference between the Female students (as % of total students) in Tertiary education and Female students (as % of total students) in Secondary general education?
Offer a very short reply. 0.36. In the year 1975, what is the difference between the Female students (as % of total students) of Tertiary education and Female students (as % of total students) of Secondary vocational education?
Keep it short and to the point. -4.43. In the year 1975, what is the difference between the Female students (as % of total students) of Secondary general education and Female students (as % of total students) of Secondary vocational education?
Your answer should be compact. -4.79. In the year 1976, what is the difference between the Female students (as % of total students) in Primary education and Female students (as % of total students) in Tertiary education?
Ensure brevity in your answer.  -5.18. In the year 1976, what is the difference between the Female students (as % of total students) in Primary education and Female students (as % of total students) in Secondary general education?
Your answer should be compact. -3.21. In the year 1976, what is the difference between the Female students (as % of total students) of Primary education and Female students (as % of total students) of Secondary vocational education?
Offer a terse response. -6.43. In the year 1976, what is the difference between the Female students (as % of total students) in Tertiary education and Female students (as % of total students) in Secondary general education?
Keep it short and to the point. 1.98. In the year 1976, what is the difference between the Female students (as % of total students) of Tertiary education and Female students (as % of total students) of Secondary vocational education?
Keep it short and to the point. -1.25. In the year 1976, what is the difference between the Female students (as % of total students) in Secondary general education and Female students (as % of total students) in Secondary vocational education?
Provide a short and direct response. -3.22. In the year 1977, what is the difference between the Female students (as % of total students) of Primary education and Female students (as % of total students) of Tertiary education?
Ensure brevity in your answer.  -5.49. In the year 1977, what is the difference between the Female students (as % of total students) in Primary education and Female students (as % of total students) in Secondary general education?
Keep it short and to the point. -3.74. In the year 1977, what is the difference between the Female students (as % of total students) in Primary education and Female students (as % of total students) in Secondary vocational education?
Ensure brevity in your answer.  -11.99. In the year 1977, what is the difference between the Female students (as % of total students) in Tertiary education and Female students (as % of total students) in Secondary general education?
Make the answer very short. 1.75. In the year 1977, what is the difference between the Female students (as % of total students) in Tertiary education and Female students (as % of total students) in Secondary vocational education?
Make the answer very short. -6.5. In the year 1977, what is the difference between the Female students (as % of total students) in Secondary general education and Female students (as % of total students) in Secondary vocational education?
Your answer should be very brief. -8.25. In the year 1978, what is the difference between the Female students (as % of total students) of Primary education and Female students (as % of total students) of Tertiary education?
Provide a succinct answer. -4.96. In the year 1978, what is the difference between the Female students (as % of total students) in Primary education and Female students (as % of total students) in Secondary general education?
Your answer should be compact. -3.93. In the year 1978, what is the difference between the Female students (as % of total students) in Primary education and Female students (as % of total students) in Secondary vocational education?
Your answer should be compact. -5.57. In the year 1978, what is the difference between the Female students (as % of total students) of Tertiary education and Female students (as % of total students) of Secondary general education?
Provide a succinct answer. 1.02. In the year 1978, what is the difference between the Female students (as % of total students) in Tertiary education and Female students (as % of total students) in Secondary vocational education?
Your answer should be very brief. -0.62. In the year 1978, what is the difference between the Female students (as % of total students) in Secondary general education and Female students (as % of total students) in Secondary vocational education?
Provide a succinct answer. -1.64. What is the ratio of the Female students (as % of total students) of Tertiary education in 1972 to that in 1973?
Provide a short and direct response. 0.99. What is the ratio of the Female students (as % of total students) of Secondary general education in 1972 to that in 1973?
Your response must be concise. 0.97. What is the ratio of the Female students (as % of total students) of Secondary vocational education in 1972 to that in 1973?
Provide a short and direct response. 1.04. What is the ratio of the Female students (as % of total students) in Primary education in 1972 to that in 1974?
Provide a short and direct response. 1. What is the ratio of the Female students (as % of total students) in Tertiary education in 1972 to that in 1974?
Keep it short and to the point. 0.97. What is the ratio of the Female students (as % of total students) of Secondary general education in 1972 to that in 1974?
Offer a terse response. 0.98. What is the ratio of the Female students (as % of total students) of Secondary vocational education in 1972 to that in 1974?
Keep it short and to the point. 0.86. What is the ratio of the Female students (as % of total students) in Tertiary education in 1972 to that in 1975?
Offer a very short reply. 0.97. What is the ratio of the Female students (as % of total students) in Secondary general education in 1972 to that in 1975?
Make the answer very short. 0.98. What is the ratio of the Female students (as % of total students) in Secondary vocational education in 1972 to that in 1975?
Your answer should be compact. 0.9. What is the ratio of the Female students (as % of total students) in Tertiary education in 1972 to that in 1976?
Offer a very short reply. 0.93. What is the ratio of the Female students (as % of total students) in Secondary general education in 1972 to that in 1976?
Offer a very short reply. 0.97. What is the ratio of the Female students (as % of total students) of Secondary vocational education in 1972 to that in 1976?
Your answer should be very brief. 0.91. What is the ratio of the Female students (as % of total students) of Primary education in 1972 to that in 1977?
Offer a terse response. 1.01. What is the ratio of the Female students (as % of total students) of Tertiary education in 1972 to that in 1977?
Make the answer very short. 0.93. What is the ratio of the Female students (as % of total students) of Secondary general education in 1972 to that in 1977?
Ensure brevity in your answer.  0.96. What is the ratio of the Female students (as % of total students) of Secondary vocational education in 1972 to that in 1977?
Offer a very short reply. 0.83. What is the ratio of the Female students (as % of total students) of Primary education in 1972 to that in 1978?
Keep it short and to the point. 1.01. What is the ratio of the Female students (as % of total students) of Tertiary education in 1972 to that in 1978?
Ensure brevity in your answer.  0.94. What is the ratio of the Female students (as % of total students) in Secondary general education in 1972 to that in 1978?
Provide a short and direct response. 0.95. What is the ratio of the Female students (as % of total students) in Secondary vocational education in 1972 to that in 1978?
Your answer should be very brief. 0.93. What is the ratio of the Female students (as % of total students) of Primary education in 1973 to that in 1974?
Your answer should be compact. 1. What is the ratio of the Female students (as % of total students) in Secondary general education in 1973 to that in 1974?
Your answer should be compact. 1.01. What is the ratio of the Female students (as % of total students) in Secondary vocational education in 1973 to that in 1974?
Provide a succinct answer. 0.83. What is the ratio of the Female students (as % of total students) of Primary education in 1973 to that in 1975?
Keep it short and to the point. 1. What is the ratio of the Female students (as % of total students) of Tertiary education in 1973 to that in 1975?
Your answer should be very brief. 0.98. What is the ratio of the Female students (as % of total students) in Secondary general education in 1973 to that in 1975?
Keep it short and to the point. 1.01. What is the ratio of the Female students (as % of total students) of Secondary vocational education in 1973 to that in 1975?
Provide a short and direct response. 0.87. What is the ratio of the Female students (as % of total students) of Primary education in 1973 to that in 1976?
Ensure brevity in your answer.  1. What is the ratio of the Female students (as % of total students) of Tertiary education in 1973 to that in 1976?
Provide a short and direct response. 0.94. What is the ratio of the Female students (as % of total students) of Secondary general education in 1973 to that in 1976?
Ensure brevity in your answer.  0.99. What is the ratio of the Female students (as % of total students) of Secondary vocational education in 1973 to that in 1976?
Provide a succinct answer. 0.88. What is the ratio of the Female students (as % of total students) in Primary education in 1973 to that in 1977?
Your response must be concise. 1.01. What is the ratio of the Female students (as % of total students) of Tertiary education in 1973 to that in 1977?
Provide a succinct answer. 0.94. What is the ratio of the Female students (as % of total students) in Secondary general education in 1973 to that in 1977?
Ensure brevity in your answer.  0.99. What is the ratio of the Female students (as % of total students) of Secondary vocational education in 1973 to that in 1977?
Offer a terse response. 0.8. What is the ratio of the Female students (as % of total students) in Primary education in 1973 to that in 1978?
Your response must be concise. 1. What is the ratio of the Female students (as % of total students) in Tertiary education in 1973 to that in 1978?
Your answer should be very brief. 0.95. What is the ratio of the Female students (as % of total students) of Secondary general education in 1973 to that in 1978?
Your answer should be compact. 0.98. What is the ratio of the Female students (as % of total students) in Secondary vocational education in 1973 to that in 1978?
Offer a very short reply. 0.9. What is the ratio of the Female students (as % of total students) of Primary education in 1974 to that in 1975?
Provide a short and direct response. 1. What is the ratio of the Female students (as % of total students) in Tertiary education in 1974 to that in 1975?
Provide a short and direct response. 1. What is the ratio of the Female students (as % of total students) in Secondary vocational education in 1974 to that in 1975?
Ensure brevity in your answer.  1.04. What is the ratio of the Female students (as % of total students) in Tertiary education in 1974 to that in 1976?
Make the answer very short. 0.96. What is the ratio of the Female students (as % of total students) in Secondary general education in 1974 to that in 1976?
Offer a terse response. 0.98. What is the ratio of the Female students (as % of total students) in Secondary vocational education in 1974 to that in 1976?
Provide a short and direct response. 1.06. What is the ratio of the Female students (as % of total students) in Primary education in 1974 to that in 1977?
Provide a short and direct response. 1. What is the ratio of the Female students (as % of total students) in Tertiary education in 1974 to that in 1977?
Keep it short and to the point. 0.95. What is the ratio of the Female students (as % of total students) of Secondary general education in 1974 to that in 1977?
Provide a succinct answer. 0.98. What is the ratio of the Female students (as % of total students) of Secondary vocational education in 1974 to that in 1977?
Provide a short and direct response. 0.96. What is the ratio of the Female students (as % of total students) of Primary education in 1974 to that in 1978?
Offer a terse response. 1. What is the ratio of the Female students (as % of total students) in Tertiary education in 1974 to that in 1978?
Give a very brief answer. 0.96. What is the ratio of the Female students (as % of total students) in Secondary general education in 1974 to that in 1978?
Provide a succinct answer. 0.97. What is the ratio of the Female students (as % of total students) in Secondary vocational education in 1974 to that in 1978?
Your answer should be very brief. 1.07. What is the ratio of the Female students (as % of total students) in Tertiary education in 1975 to that in 1976?
Offer a very short reply. 0.96. What is the ratio of the Female students (as % of total students) in Secondary vocational education in 1975 to that in 1976?
Provide a short and direct response. 1.02. What is the ratio of the Female students (as % of total students) in Tertiary education in 1975 to that in 1977?
Your response must be concise. 0.96. What is the ratio of the Female students (as % of total students) in Secondary vocational education in 1975 to that in 1977?
Your answer should be compact. 0.93. What is the ratio of the Female students (as % of total students) of Primary education in 1975 to that in 1978?
Your answer should be compact. 1. What is the ratio of the Female students (as % of total students) of Tertiary education in 1975 to that in 1978?
Keep it short and to the point. 0.96. What is the ratio of the Female students (as % of total students) in Secondary general education in 1975 to that in 1978?
Your answer should be compact. 0.98. What is the ratio of the Female students (as % of total students) of Secondary vocational education in 1975 to that in 1978?
Offer a terse response. 1.03. What is the ratio of the Female students (as % of total students) of Primary education in 1976 to that in 1977?
Provide a succinct answer. 1. What is the ratio of the Female students (as % of total students) of Secondary general education in 1976 to that in 1977?
Your answer should be very brief. 0.99. What is the ratio of the Female students (as % of total students) of Secondary vocational education in 1976 to that in 1977?
Your answer should be very brief. 0.91. What is the ratio of the Female students (as % of total students) of Primary education in 1976 to that in 1978?
Offer a very short reply. 1. What is the ratio of the Female students (as % of total students) in Tertiary education in 1976 to that in 1978?
Your response must be concise. 1. What is the ratio of the Female students (as % of total students) of Secondary general education in 1976 to that in 1978?
Ensure brevity in your answer.  0.99. What is the ratio of the Female students (as % of total students) in Secondary vocational education in 1976 to that in 1978?
Your response must be concise. 1.02. What is the ratio of the Female students (as % of total students) of Secondary general education in 1977 to that in 1978?
Your response must be concise. 1. What is the ratio of the Female students (as % of total students) of Secondary vocational education in 1977 to that in 1978?
Give a very brief answer. 1.12. What is the difference between the highest and the second highest Female students (as % of total students) of Primary education?
Your answer should be compact. 0.03. What is the difference between the highest and the second highest Female students (as % of total students) of Tertiary education?
Ensure brevity in your answer.  0.23. What is the difference between the highest and the second highest Female students (as % of total students) of Secondary general education?
Offer a terse response. 0.24. What is the difference between the highest and the second highest Female students (as % of total students) of Secondary vocational education?
Provide a short and direct response. 2.31. What is the difference between the highest and the lowest Female students (as % of total students) in Primary education?
Ensure brevity in your answer.  0.3. What is the difference between the highest and the lowest Female students (as % of total students) of Tertiary education?
Provide a succinct answer. 3.96. What is the difference between the highest and the lowest Female students (as % of total students) in Secondary general education?
Make the answer very short. 2.51. What is the difference between the highest and the lowest Female students (as % of total students) in Secondary vocational education?
Give a very brief answer. 12.05. 